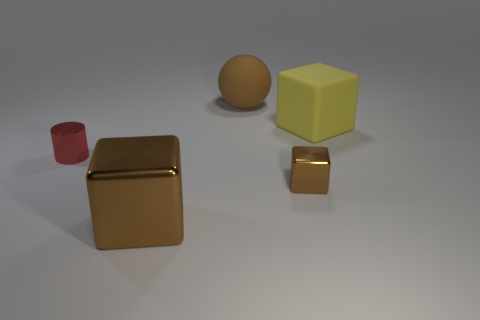There is another cube that is the same color as the small block; what is its size?
Offer a terse response. Large. What number of shiny things have the same color as the large metal cube?
Ensure brevity in your answer.  1. There is a brown sphere; is it the same size as the yellow thing behind the tiny metallic block?
Your response must be concise. Yes. Are there any cylinders that have the same size as the yellow rubber thing?
Ensure brevity in your answer.  No. How many things are either small cylinders or brown things?
Your response must be concise. 4. There is a rubber object that is on the right side of the small metal block; does it have the same size as the rubber thing behind the yellow rubber block?
Make the answer very short. Yes. Are there any large metallic objects that have the same shape as the small brown thing?
Make the answer very short. Yes. Are there fewer brown matte balls that are to the right of the small shiny cube than large things?
Give a very brief answer. Yes. Does the brown rubber object have the same shape as the tiny red object?
Provide a short and direct response. No. What is the size of the brown thing that is to the left of the large brown matte ball?
Offer a terse response. Large. 